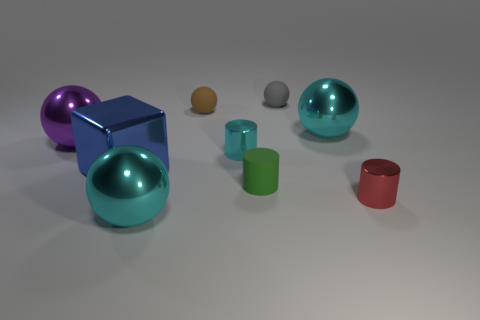Subtract all brown balls. How many balls are left? 4 Subtract all shiny cylinders. How many cylinders are left? 1 Subtract 2 spheres. How many spheres are left? 3 Subtract all brown spheres. Subtract all green cubes. How many spheres are left? 4 Subtract all spheres. How many objects are left? 4 Add 4 red cylinders. How many red cylinders are left? 5 Add 4 brown matte objects. How many brown matte objects exist? 5 Subtract 0 yellow spheres. How many objects are left? 9 Subtract all tiny spheres. Subtract all green matte cylinders. How many objects are left? 6 